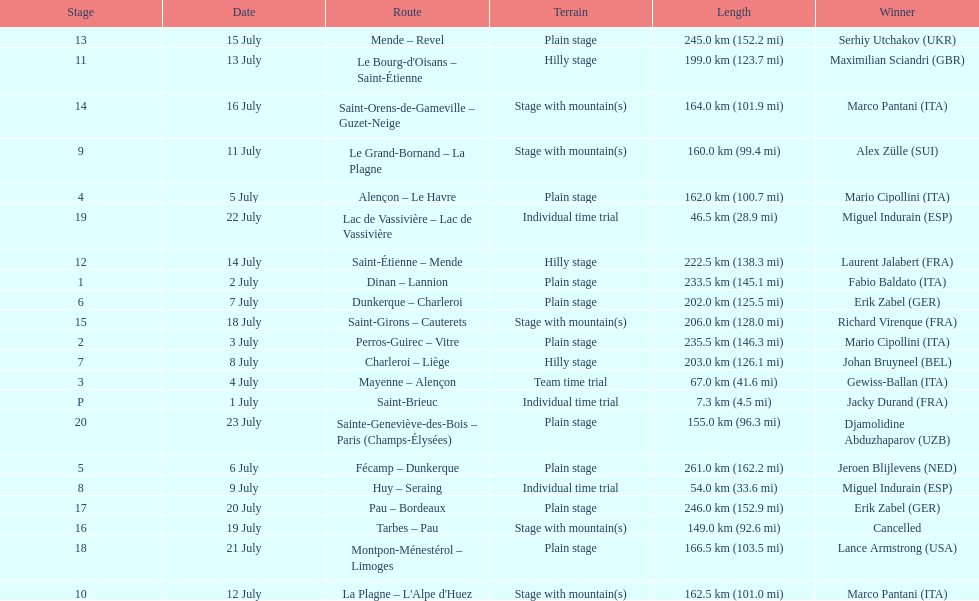How many routes have below 100 km total? 4. 